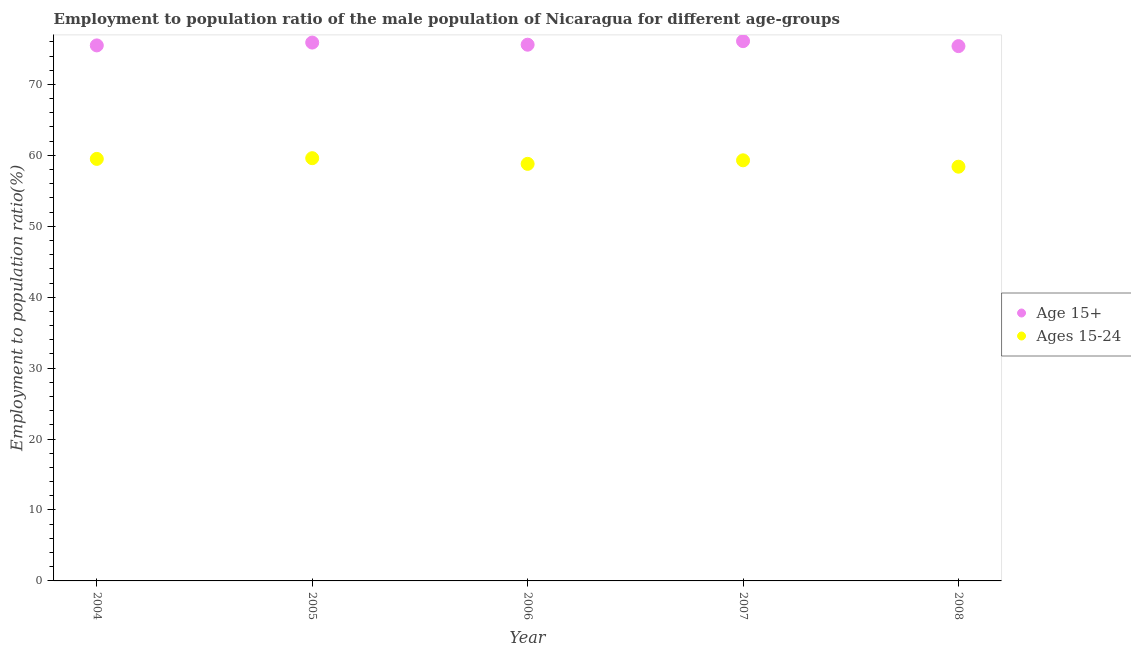How many different coloured dotlines are there?
Provide a succinct answer. 2. What is the employment to population ratio(age 15-24) in 2005?
Your answer should be compact. 59.6. Across all years, what is the maximum employment to population ratio(age 15-24)?
Provide a succinct answer. 59.6. Across all years, what is the minimum employment to population ratio(age 15-24)?
Provide a short and direct response. 58.4. What is the total employment to population ratio(age 15-24) in the graph?
Make the answer very short. 295.6. What is the difference between the employment to population ratio(age 15+) in 2004 and that in 2006?
Make the answer very short. -0.1. What is the difference between the employment to population ratio(age 15+) in 2007 and the employment to population ratio(age 15-24) in 2005?
Your answer should be very brief. 16.5. What is the average employment to population ratio(age 15+) per year?
Your answer should be compact. 75.7. In the year 2007, what is the difference between the employment to population ratio(age 15+) and employment to population ratio(age 15-24)?
Give a very brief answer. 16.8. What is the ratio of the employment to population ratio(age 15+) in 2005 to that in 2006?
Keep it short and to the point. 1. Is the employment to population ratio(age 15-24) in 2007 less than that in 2008?
Offer a terse response. No. Is the difference between the employment to population ratio(age 15+) in 2005 and 2007 greater than the difference between the employment to population ratio(age 15-24) in 2005 and 2007?
Provide a short and direct response. No. What is the difference between the highest and the second highest employment to population ratio(age 15+)?
Provide a succinct answer. 0.2. What is the difference between the highest and the lowest employment to population ratio(age 15+)?
Keep it short and to the point. 0.7. In how many years, is the employment to population ratio(age 15+) greater than the average employment to population ratio(age 15+) taken over all years?
Make the answer very short. 2. Is the sum of the employment to population ratio(age 15+) in 2007 and 2008 greater than the maximum employment to population ratio(age 15-24) across all years?
Give a very brief answer. Yes. Does the employment to population ratio(age 15+) monotonically increase over the years?
Your answer should be very brief. No. Is the employment to population ratio(age 15+) strictly greater than the employment to population ratio(age 15-24) over the years?
Your answer should be very brief. Yes. How many years are there in the graph?
Offer a terse response. 5. Does the graph contain any zero values?
Offer a very short reply. No. Does the graph contain grids?
Make the answer very short. No. Where does the legend appear in the graph?
Provide a succinct answer. Center right. What is the title of the graph?
Provide a succinct answer. Employment to population ratio of the male population of Nicaragua for different age-groups. What is the label or title of the Y-axis?
Keep it short and to the point. Employment to population ratio(%). What is the Employment to population ratio(%) of Age 15+ in 2004?
Your answer should be very brief. 75.5. What is the Employment to population ratio(%) in Ages 15-24 in 2004?
Keep it short and to the point. 59.5. What is the Employment to population ratio(%) in Age 15+ in 2005?
Your answer should be very brief. 75.9. What is the Employment to population ratio(%) in Ages 15-24 in 2005?
Ensure brevity in your answer.  59.6. What is the Employment to population ratio(%) of Age 15+ in 2006?
Your answer should be very brief. 75.6. What is the Employment to population ratio(%) in Ages 15-24 in 2006?
Keep it short and to the point. 58.8. What is the Employment to population ratio(%) of Age 15+ in 2007?
Keep it short and to the point. 76.1. What is the Employment to population ratio(%) of Ages 15-24 in 2007?
Provide a short and direct response. 59.3. What is the Employment to population ratio(%) of Age 15+ in 2008?
Provide a short and direct response. 75.4. What is the Employment to population ratio(%) of Ages 15-24 in 2008?
Your answer should be very brief. 58.4. Across all years, what is the maximum Employment to population ratio(%) in Age 15+?
Your response must be concise. 76.1. Across all years, what is the maximum Employment to population ratio(%) of Ages 15-24?
Offer a terse response. 59.6. Across all years, what is the minimum Employment to population ratio(%) in Age 15+?
Offer a terse response. 75.4. Across all years, what is the minimum Employment to population ratio(%) in Ages 15-24?
Your answer should be very brief. 58.4. What is the total Employment to population ratio(%) in Age 15+ in the graph?
Your answer should be compact. 378.5. What is the total Employment to population ratio(%) of Ages 15-24 in the graph?
Provide a short and direct response. 295.6. What is the difference between the Employment to population ratio(%) of Age 15+ in 2004 and that in 2006?
Keep it short and to the point. -0.1. What is the difference between the Employment to population ratio(%) of Age 15+ in 2004 and that in 2008?
Offer a terse response. 0.1. What is the difference between the Employment to population ratio(%) in Age 15+ in 2005 and that in 2006?
Offer a very short reply. 0.3. What is the difference between the Employment to population ratio(%) in Age 15+ in 2005 and that in 2007?
Provide a succinct answer. -0.2. What is the difference between the Employment to population ratio(%) of Age 15+ in 2005 and that in 2008?
Give a very brief answer. 0.5. What is the difference between the Employment to population ratio(%) of Ages 15-24 in 2005 and that in 2008?
Your answer should be compact. 1.2. What is the difference between the Employment to population ratio(%) in Age 15+ in 2004 and the Employment to population ratio(%) in Ages 15-24 in 2006?
Keep it short and to the point. 16.7. What is the difference between the Employment to population ratio(%) in Age 15+ in 2004 and the Employment to population ratio(%) in Ages 15-24 in 2008?
Give a very brief answer. 17.1. What is the difference between the Employment to population ratio(%) in Age 15+ in 2006 and the Employment to population ratio(%) in Ages 15-24 in 2007?
Make the answer very short. 16.3. What is the difference between the Employment to population ratio(%) of Age 15+ in 2007 and the Employment to population ratio(%) of Ages 15-24 in 2008?
Provide a short and direct response. 17.7. What is the average Employment to population ratio(%) in Age 15+ per year?
Your response must be concise. 75.7. What is the average Employment to population ratio(%) of Ages 15-24 per year?
Offer a terse response. 59.12. In the year 2004, what is the difference between the Employment to population ratio(%) in Age 15+ and Employment to population ratio(%) in Ages 15-24?
Make the answer very short. 16. In the year 2008, what is the difference between the Employment to population ratio(%) in Age 15+ and Employment to population ratio(%) in Ages 15-24?
Provide a succinct answer. 17. What is the ratio of the Employment to population ratio(%) in Ages 15-24 in 2004 to that in 2006?
Make the answer very short. 1.01. What is the ratio of the Employment to population ratio(%) of Age 15+ in 2004 to that in 2007?
Offer a very short reply. 0.99. What is the ratio of the Employment to population ratio(%) of Ages 15-24 in 2004 to that in 2007?
Ensure brevity in your answer.  1. What is the ratio of the Employment to population ratio(%) in Age 15+ in 2004 to that in 2008?
Offer a very short reply. 1. What is the ratio of the Employment to population ratio(%) in Ages 15-24 in 2004 to that in 2008?
Ensure brevity in your answer.  1.02. What is the ratio of the Employment to population ratio(%) of Ages 15-24 in 2005 to that in 2006?
Your response must be concise. 1.01. What is the ratio of the Employment to population ratio(%) in Ages 15-24 in 2005 to that in 2007?
Your answer should be very brief. 1.01. What is the ratio of the Employment to population ratio(%) of Age 15+ in 2005 to that in 2008?
Ensure brevity in your answer.  1.01. What is the ratio of the Employment to population ratio(%) in Ages 15-24 in 2005 to that in 2008?
Provide a short and direct response. 1.02. What is the ratio of the Employment to population ratio(%) of Ages 15-24 in 2006 to that in 2007?
Keep it short and to the point. 0.99. What is the ratio of the Employment to population ratio(%) of Ages 15-24 in 2006 to that in 2008?
Your answer should be very brief. 1.01. What is the ratio of the Employment to population ratio(%) in Age 15+ in 2007 to that in 2008?
Give a very brief answer. 1.01. What is the ratio of the Employment to population ratio(%) of Ages 15-24 in 2007 to that in 2008?
Offer a very short reply. 1.02. What is the difference between the highest and the second highest Employment to population ratio(%) in Age 15+?
Provide a succinct answer. 0.2. What is the difference between the highest and the lowest Employment to population ratio(%) of Ages 15-24?
Provide a short and direct response. 1.2. 